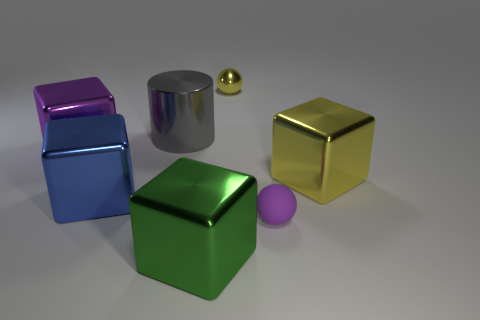Subtract 4 cubes. How many cubes are left? 0 Add 2 small purple matte spheres. How many objects exist? 9 Subtract all purple blocks. How many blocks are left? 3 Subtract all spheres. How many objects are left? 5 Subtract 1 gray cylinders. How many objects are left? 6 Subtract all purple cylinders. Subtract all gray spheres. How many cylinders are left? 1 Subtract all gray balls. How many yellow cylinders are left? 0 Subtract all small yellow matte balls. Subtract all purple cubes. How many objects are left? 6 Add 4 purple metal blocks. How many purple metal blocks are left? 5 Add 2 big purple metal blocks. How many big purple metal blocks exist? 3 